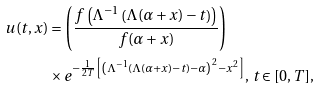<formula> <loc_0><loc_0><loc_500><loc_500>u ( t , x ) & = \left ( \frac { f \left ( \Lambda ^ { - 1 } \left ( \Lambda ( \alpha + x ) - t \right ) \right ) } { f ( \alpha + x ) } \right ) \\ & \times e ^ { - \frac { 1 } { 2 T } \left [ \left ( \Lambda ^ { - 1 } \left ( \Lambda ( \alpha + x ) - t \right ) - \alpha \right ) ^ { 2 } - x ^ { 2 } \right ] } , \, t \in [ 0 , T ] ,</formula> 